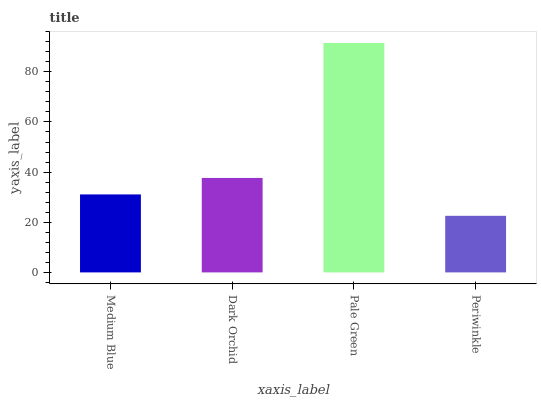Is Periwinkle the minimum?
Answer yes or no. Yes. Is Pale Green the maximum?
Answer yes or no. Yes. Is Dark Orchid the minimum?
Answer yes or no. No. Is Dark Orchid the maximum?
Answer yes or no. No. Is Dark Orchid greater than Medium Blue?
Answer yes or no. Yes. Is Medium Blue less than Dark Orchid?
Answer yes or no. Yes. Is Medium Blue greater than Dark Orchid?
Answer yes or no. No. Is Dark Orchid less than Medium Blue?
Answer yes or no. No. Is Dark Orchid the high median?
Answer yes or no. Yes. Is Medium Blue the low median?
Answer yes or no. Yes. Is Medium Blue the high median?
Answer yes or no. No. Is Periwinkle the low median?
Answer yes or no. No. 